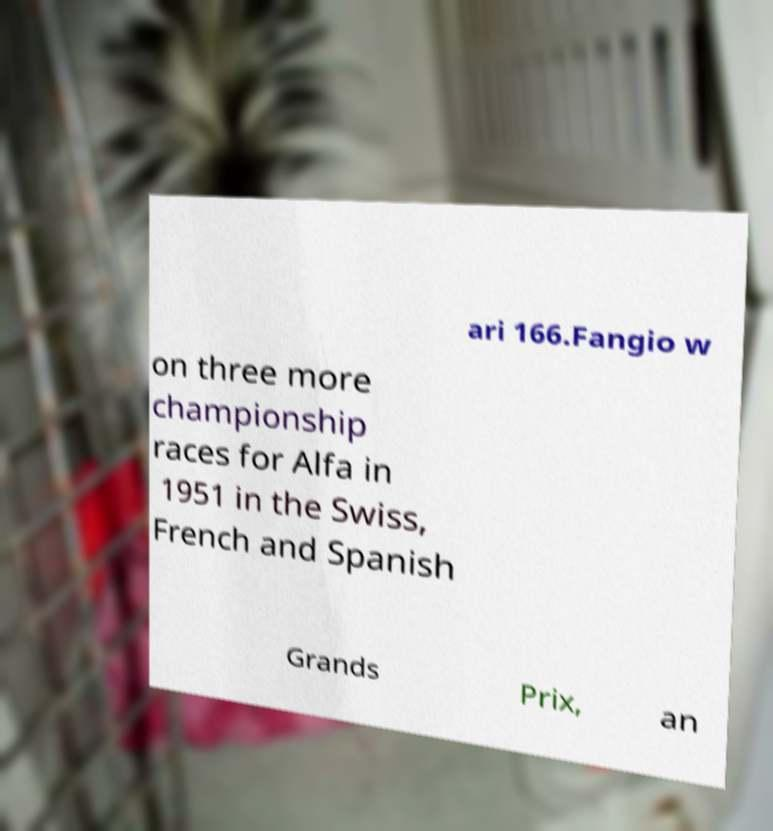There's text embedded in this image that I need extracted. Can you transcribe it verbatim? ari 166.Fangio w on three more championship races for Alfa in 1951 in the Swiss, French and Spanish Grands Prix, an 